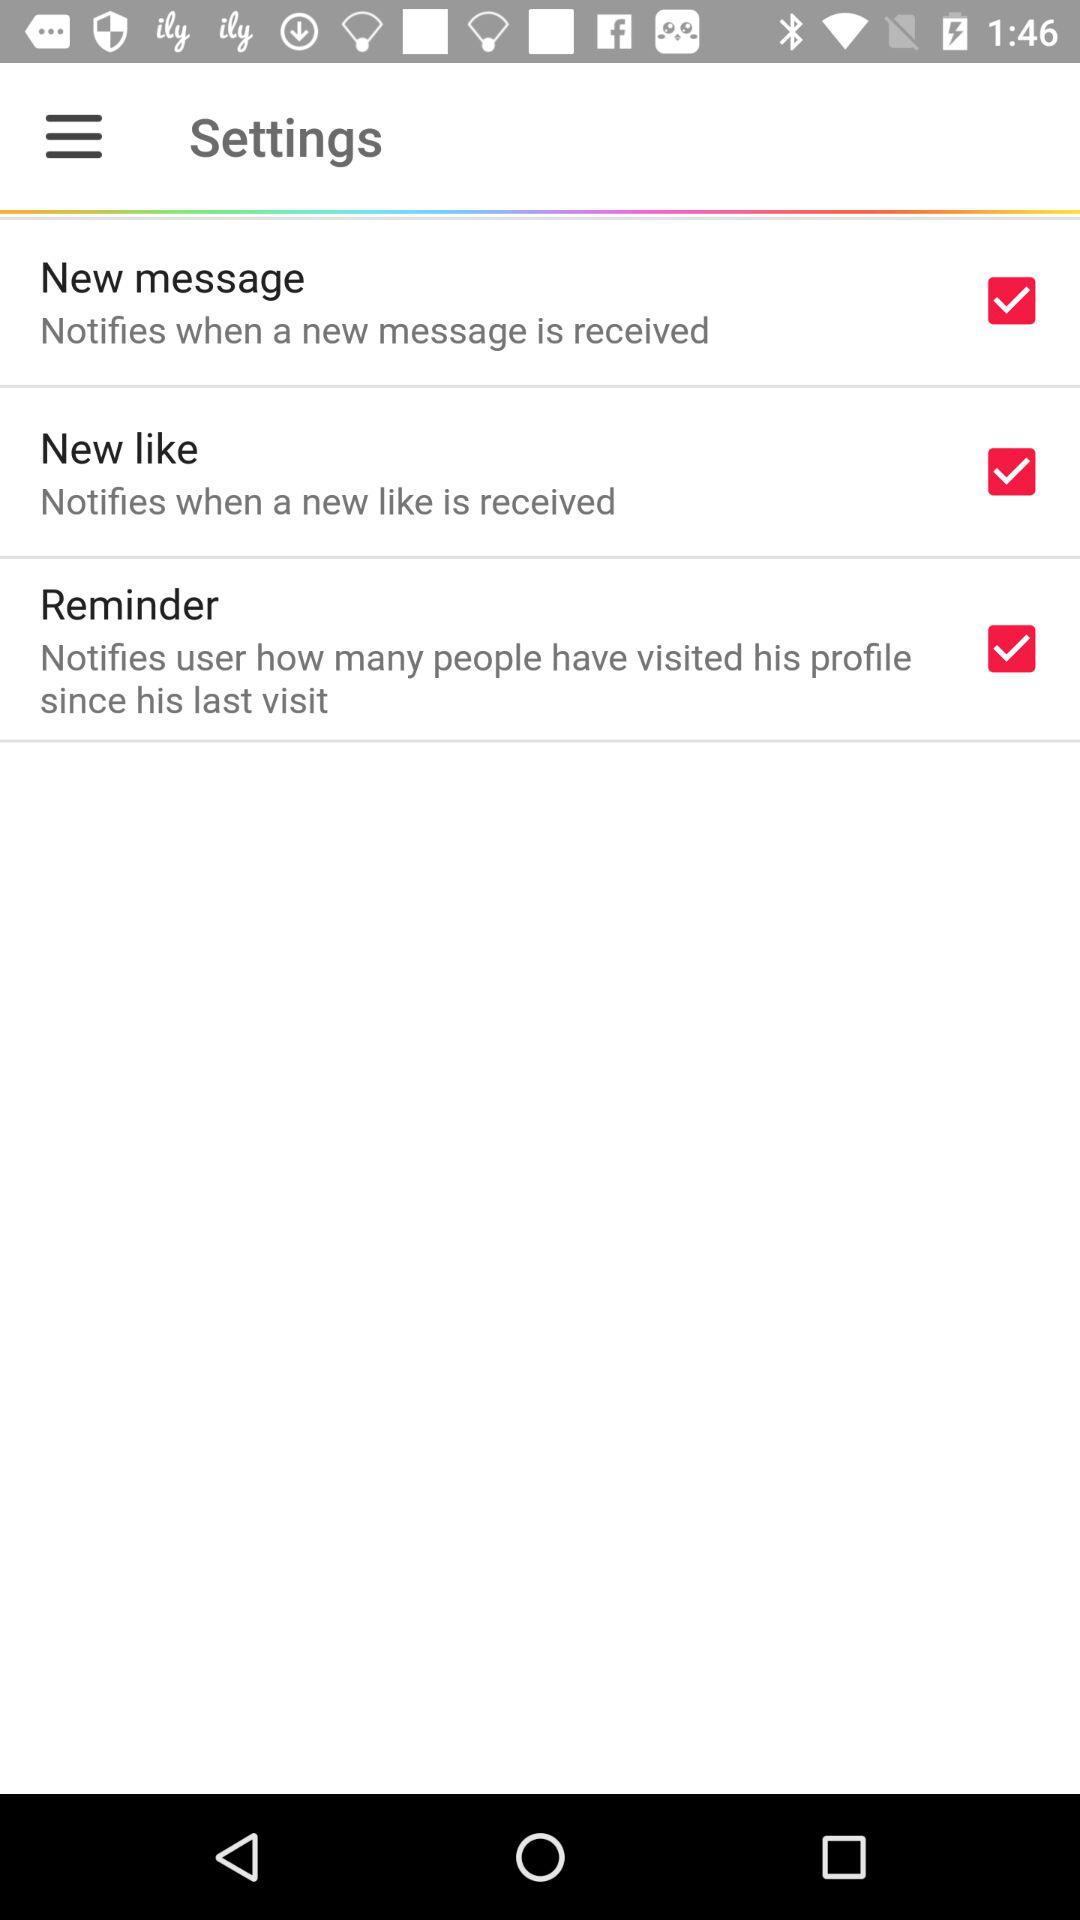What's the status of "New like"?
Answer the question using a single word or phrase. The status is"on". 